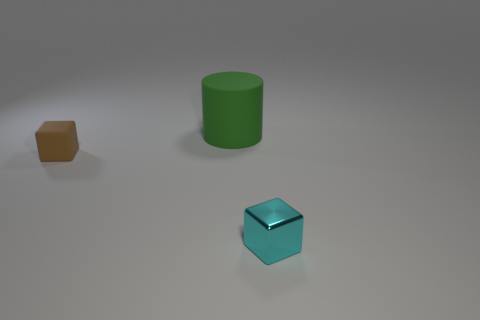Add 3 brown things. How many objects exist? 6 Subtract all cylinders. How many objects are left? 2 Subtract 1 brown blocks. How many objects are left? 2 Subtract all cyan metal blocks. Subtract all small cyan metallic blocks. How many objects are left? 1 Add 2 cylinders. How many cylinders are left? 3 Add 3 tiny matte objects. How many tiny matte objects exist? 4 